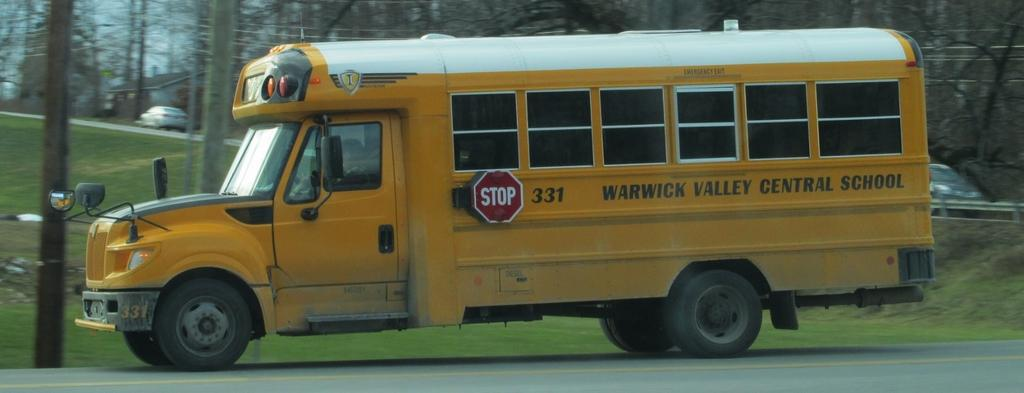What type of vehicle is on the road in the image? There is a yellow bus on the road in the image. What else can be seen along the road in the image? There are poles and cars visible in the image. What type of natural elements are present in the image? Trees and plants are visible in the image. Can you see a fan in the image? There is no fan present in the image. What type of pump is visible in the image? There is no pump present in the image. 